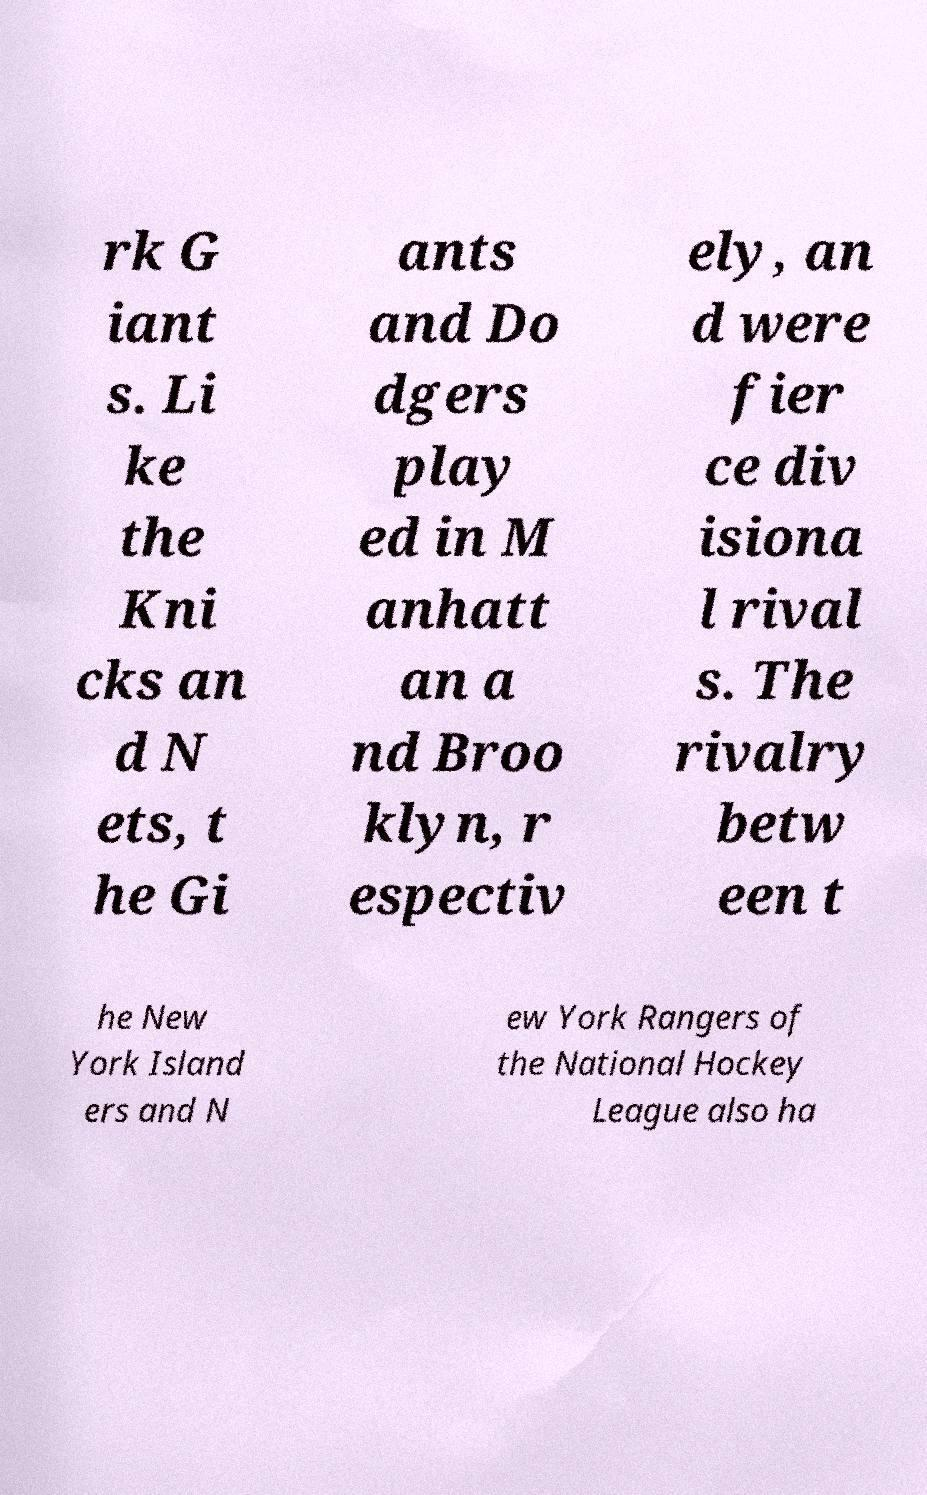Can you read and provide the text displayed in the image?This photo seems to have some interesting text. Can you extract and type it out for me? rk G iant s. Li ke the Kni cks an d N ets, t he Gi ants and Do dgers play ed in M anhatt an a nd Broo klyn, r espectiv ely, an d were fier ce div isiona l rival s. The rivalry betw een t he New York Island ers and N ew York Rangers of the National Hockey League also ha 